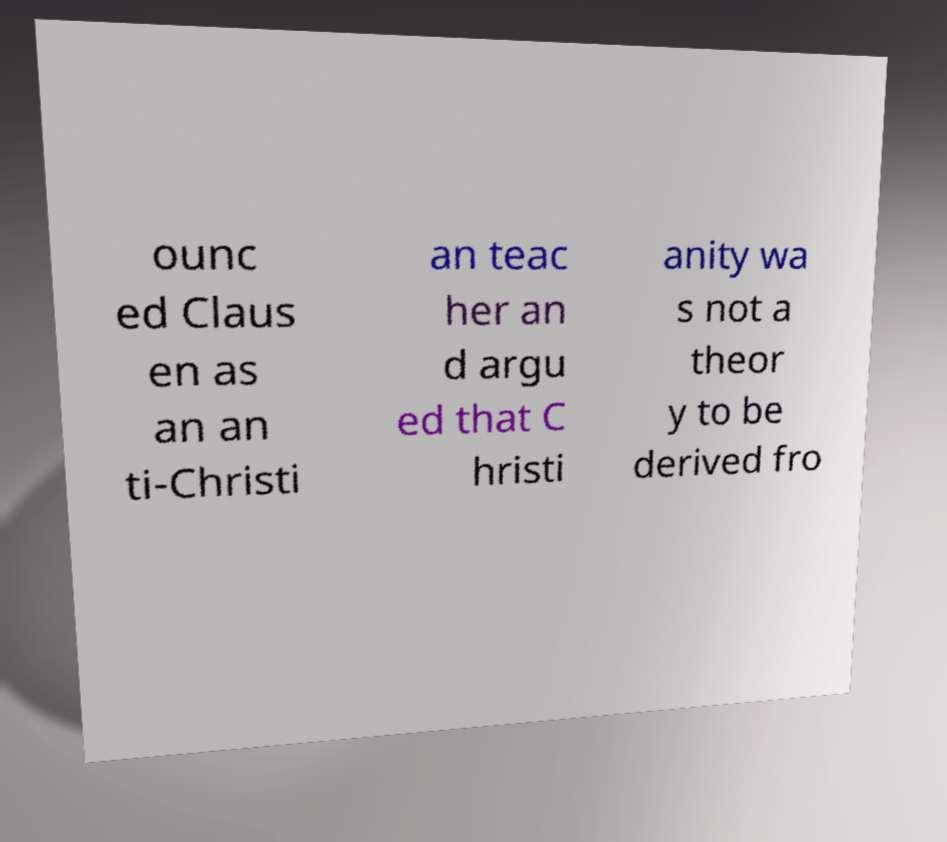There's text embedded in this image that I need extracted. Can you transcribe it verbatim? ounc ed Claus en as an an ti-Christi an teac her an d argu ed that C hristi anity wa s not a theor y to be derived fro 